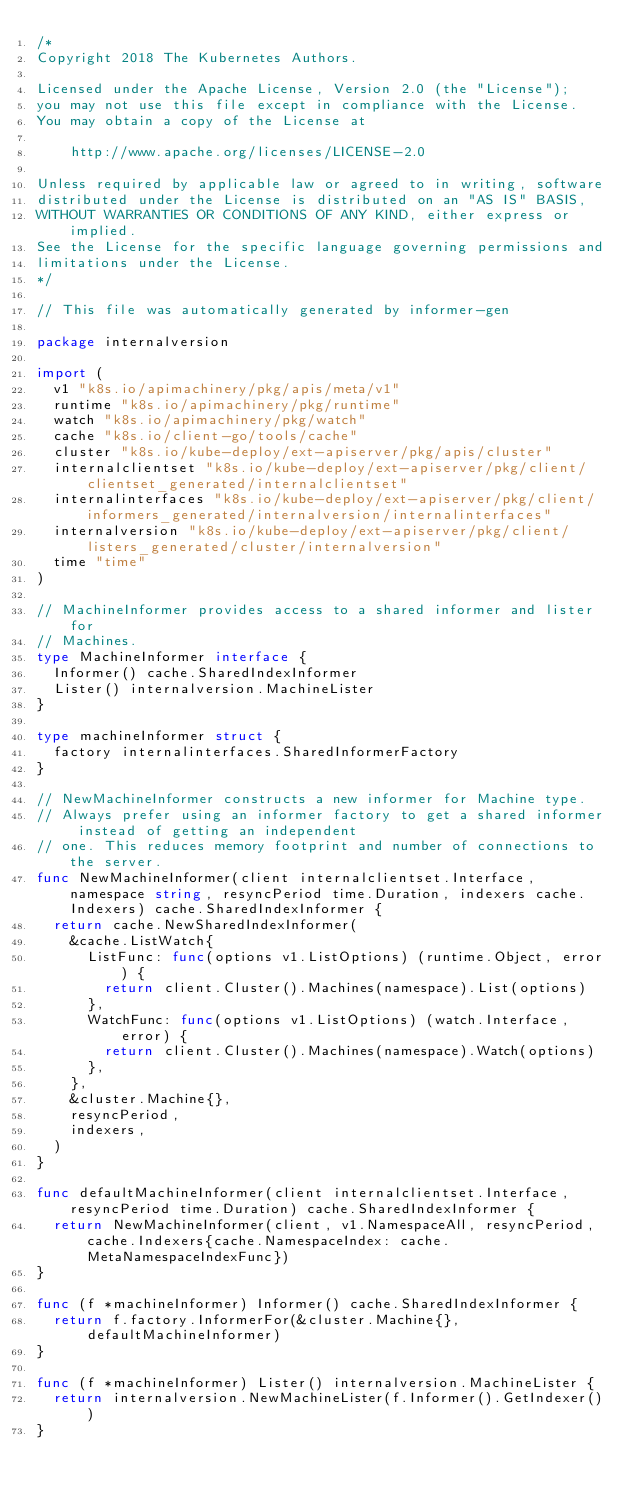<code> <loc_0><loc_0><loc_500><loc_500><_Go_>/*
Copyright 2018 The Kubernetes Authors.

Licensed under the Apache License, Version 2.0 (the "License");
you may not use this file except in compliance with the License.
You may obtain a copy of the License at

    http://www.apache.org/licenses/LICENSE-2.0

Unless required by applicable law or agreed to in writing, software
distributed under the License is distributed on an "AS IS" BASIS,
WITHOUT WARRANTIES OR CONDITIONS OF ANY KIND, either express or implied.
See the License for the specific language governing permissions and
limitations under the License.
*/

// This file was automatically generated by informer-gen

package internalversion

import (
	v1 "k8s.io/apimachinery/pkg/apis/meta/v1"
	runtime "k8s.io/apimachinery/pkg/runtime"
	watch "k8s.io/apimachinery/pkg/watch"
	cache "k8s.io/client-go/tools/cache"
	cluster "k8s.io/kube-deploy/ext-apiserver/pkg/apis/cluster"
	internalclientset "k8s.io/kube-deploy/ext-apiserver/pkg/client/clientset_generated/internalclientset"
	internalinterfaces "k8s.io/kube-deploy/ext-apiserver/pkg/client/informers_generated/internalversion/internalinterfaces"
	internalversion "k8s.io/kube-deploy/ext-apiserver/pkg/client/listers_generated/cluster/internalversion"
	time "time"
)

// MachineInformer provides access to a shared informer and lister for
// Machines.
type MachineInformer interface {
	Informer() cache.SharedIndexInformer
	Lister() internalversion.MachineLister
}

type machineInformer struct {
	factory internalinterfaces.SharedInformerFactory
}

// NewMachineInformer constructs a new informer for Machine type.
// Always prefer using an informer factory to get a shared informer instead of getting an independent
// one. This reduces memory footprint and number of connections to the server.
func NewMachineInformer(client internalclientset.Interface, namespace string, resyncPeriod time.Duration, indexers cache.Indexers) cache.SharedIndexInformer {
	return cache.NewSharedIndexInformer(
		&cache.ListWatch{
			ListFunc: func(options v1.ListOptions) (runtime.Object, error) {
				return client.Cluster().Machines(namespace).List(options)
			},
			WatchFunc: func(options v1.ListOptions) (watch.Interface, error) {
				return client.Cluster().Machines(namespace).Watch(options)
			},
		},
		&cluster.Machine{},
		resyncPeriod,
		indexers,
	)
}

func defaultMachineInformer(client internalclientset.Interface, resyncPeriod time.Duration) cache.SharedIndexInformer {
	return NewMachineInformer(client, v1.NamespaceAll, resyncPeriod, cache.Indexers{cache.NamespaceIndex: cache.MetaNamespaceIndexFunc})
}

func (f *machineInformer) Informer() cache.SharedIndexInformer {
	return f.factory.InformerFor(&cluster.Machine{}, defaultMachineInformer)
}

func (f *machineInformer) Lister() internalversion.MachineLister {
	return internalversion.NewMachineLister(f.Informer().GetIndexer())
}
</code> 